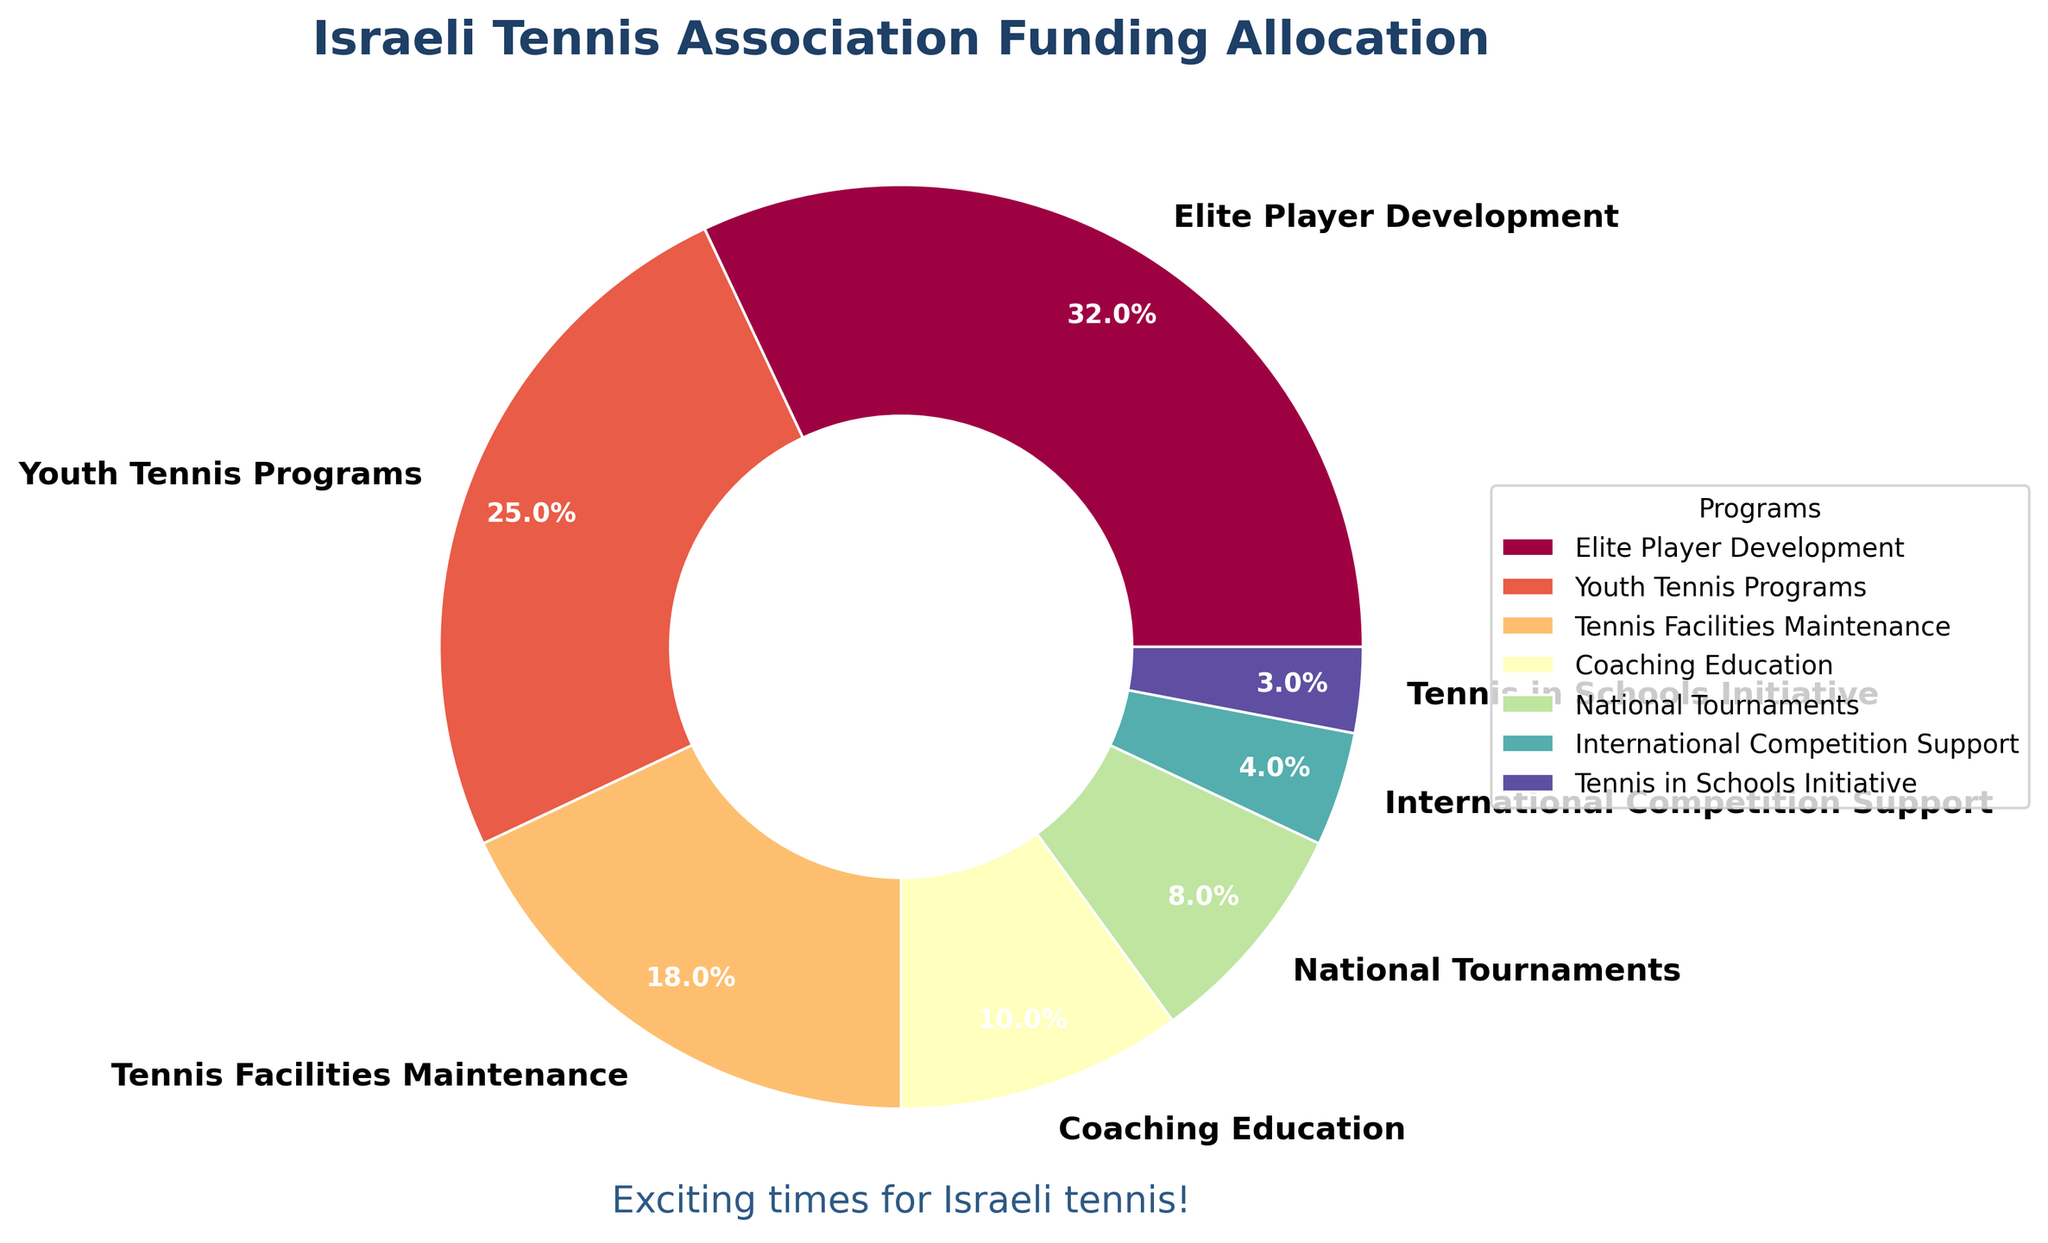Which program receives the most funding? The pie chart shows different slices representing the funding allocation. The slice labeled "Elite Player Development" is the largest.
Answer: Elite Player Development What percentage of the funding is allocated to youth programs? Look for the slice labeled "Youth Tennis Programs." The chart shows it receives 25% of the total funding.
Answer: 25% How much more funding does Elite Player Development get compared to Tennis in Schools Initiative? Elite Player Development receives 32%, and Tennis in Schools Initiative gets 3%. Subtract the smaller percentage from the larger: 32% - 3% = 29%.
Answer: 29% Which two programs receive the least amount of funding? Examine the smallest slices in the chart. "International Competition Support" and "Tennis in Schools Initiative" are the two smallest, with 4% and 3% respectively.
Answer: International Competition Support and Tennis in Schools Initiative What is the total percentage of funding allocated to Coaching Education and National Tournaments combined? Add the percentages for Coaching Education (10%) and National Tournaments (8%): 10% + 8% = 18%.
Answer: 18% How does the funding for Tennis Facilities Maintenance compare to Youth Tennis Programs? Compare their slices. Tennis Facilities Maintenance gets 18%, and Youth Tennis Programs get 25%. Therefore, Youth Tennis Programs receive a larger percentage of the funding.
Answer: Youth Tennis Programs receive more funding What visual element represents the funding allocation percentages? The pie chart uses wedges (slices) to represent different programs, with their corresponding percentages indicated on each wedge.
Answer: Wedges What program's funding is less than half of Elite Player Development but more than Coaching Education? Elite Player Development gets 32%, half of it is 16%. Coaching Education gets 10%. The slice for "Tennis Facilities Maintenance" fits this criteria at 18%.
Answer: Tennis Facilities Maintenance Which slice has the darkest color? The visual distinction can be subjective, but based on typical color maps, the largest slice (Elite Player Development) often uses a more prominent color, typically perceived as darker.
Answer: Elite Player Development 